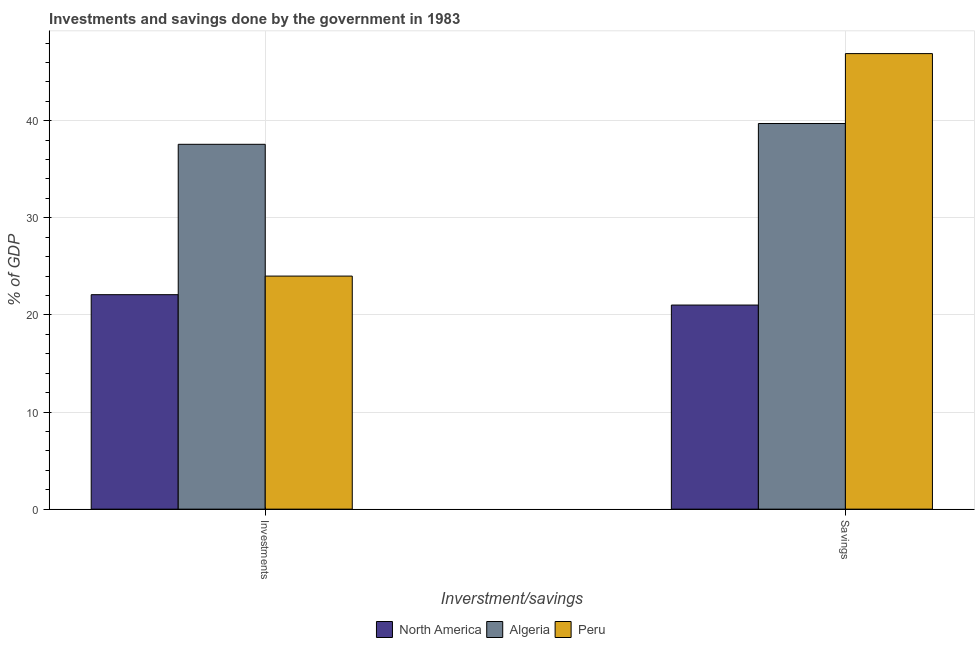How many different coloured bars are there?
Your answer should be compact. 3. How many groups of bars are there?
Ensure brevity in your answer.  2. How many bars are there on the 1st tick from the right?
Offer a very short reply. 3. What is the label of the 2nd group of bars from the left?
Give a very brief answer. Savings. What is the investments of government in North America?
Keep it short and to the point. 22.08. Across all countries, what is the maximum investments of government?
Give a very brief answer. 37.57. Across all countries, what is the minimum investments of government?
Offer a very short reply. 22.08. In which country was the savings of government maximum?
Provide a succinct answer. Peru. What is the total investments of government in the graph?
Give a very brief answer. 83.65. What is the difference between the investments of government in North America and that in Peru?
Keep it short and to the point. -1.92. What is the difference between the investments of government in North America and the savings of government in Peru?
Provide a short and direct response. -24.82. What is the average investments of government per country?
Keep it short and to the point. 27.88. What is the difference between the savings of government and investments of government in Algeria?
Give a very brief answer. 2.14. What is the ratio of the investments of government in North America to that in Peru?
Provide a succinct answer. 0.92. Is the investments of government in Algeria less than that in Peru?
Ensure brevity in your answer.  No. What does the 3rd bar from the left in Savings represents?
Provide a succinct answer. Peru. What does the 3rd bar from the right in Savings represents?
Your answer should be very brief. North America. Are all the bars in the graph horizontal?
Your answer should be very brief. No. Are the values on the major ticks of Y-axis written in scientific E-notation?
Provide a succinct answer. No. Does the graph contain any zero values?
Provide a short and direct response. No. Where does the legend appear in the graph?
Offer a terse response. Bottom center. What is the title of the graph?
Ensure brevity in your answer.  Investments and savings done by the government in 1983. Does "Kosovo" appear as one of the legend labels in the graph?
Keep it short and to the point. No. What is the label or title of the X-axis?
Provide a short and direct response. Inverstment/savings. What is the label or title of the Y-axis?
Keep it short and to the point. % of GDP. What is the % of GDP in North America in Investments?
Offer a very short reply. 22.08. What is the % of GDP in Algeria in Investments?
Provide a short and direct response. 37.57. What is the % of GDP of Peru in Investments?
Keep it short and to the point. 24. What is the % of GDP in North America in Savings?
Make the answer very short. 21.02. What is the % of GDP of Algeria in Savings?
Your answer should be very brief. 39.71. What is the % of GDP of Peru in Savings?
Your response must be concise. 46.91. Across all Inverstment/savings, what is the maximum % of GDP of North America?
Your answer should be very brief. 22.08. Across all Inverstment/savings, what is the maximum % of GDP in Algeria?
Your response must be concise. 39.71. Across all Inverstment/savings, what is the maximum % of GDP in Peru?
Give a very brief answer. 46.91. Across all Inverstment/savings, what is the minimum % of GDP in North America?
Your answer should be compact. 21.02. Across all Inverstment/savings, what is the minimum % of GDP in Algeria?
Your answer should be very brief. 37.57. Across all Inverstment/savings, what is the minimum % of GDP in Peru?
Make the answer very short. 24. What is the total % of GDP in North America in the graph?
Ensure brevity in your answer.  43.1. What is the total % of GDP in Algeria in the graph?
Offer a terse response. 77.28. What is the total % of GDP in Peru in the graph?
Give a very brief answer. 70.91. What is the difference between the % of GDP in North America in Investments and that in Savings?
Make the answer very short. 1.07. What is the difference between the % of GDP in Algeria in Investments and that in Savings?
Give a very brief answer. -2.14. What is the difference between the % of GDP in Peru in Investments and that in Savings?
Your answer should be compact. -22.91. What is the difference between the % of GDP of North America in Investments and the % of GDP of Algeria in Savings?
Your answer should be compact. -17.62. What is the difference between the % of GDP in North America in Investments and the % of GDP in Peru in Savings?
Keep it short and to the point. -24.82. What is the difference between the % of GDP of Algeria in Investments and the % of GDP of Peru in Savings?
Your answer should be very brief. -9.34. What is the average % of GDP of North America per Inverstment/savings?
Your answer should be compact. 21.55. What is the average % of GDP of Algeria per Inverstment/savings?
Your answer should be compact. 38.64. What is the average % of GDP of Peru per Inverstment/savings?
Keep it short and to the point. 35.45. What is the difference between the % of GDP in North America and % of GDP in Algeria in Investments?
Give a very brief answer. -15.49. What is the difference between the % of GDP in North America and % of GDP in Peru in Investments?
Offer a terse response. -1.92. What is the difference between the % of GDP of Algeria and % of GDP of Peru in Investments?
Your response must be concise. 13.57. What is the difference between the % of GDP in North America and % of GDP in Algeria in Savings?
Provide a short and direct response. -18.69. What is the difference between the % of GDP in North America and % of GDP in Peru in Savings?
Offer a terse response. -25.89. What is the difference between the % of GDP of Algeria and % of GDP of Peru in Savings?
Keep it short and to the point. -7.2. What is the ratio of the % of GDP of North America in Investments to that in Savings?
Give a very brief answer. 1.05. What is the ratio of the % of GDP of Algeria in Investments to that in Savings?
Make the answer very short. 0.95. What is the ratio of the % of GDP of Peru in Investments to that in Savings?
Keep it short and to the point. 0.51. What is the difference between the highest and the second highest % of GDP of North America?
Offer a terse response. 1.07. What is the difference between the highest and the second highest % of GDP in Algeria?
Make the answer very short. 2.14. What is the difference between the highest and the second highest % of GDP of Peru?
Offer a terse response. 22.91. What is the difference between the highest and the lowest % of GDP of North America?
Provide a short and direct response. 1.07. What is the difference between the highest and the lowest % of GDP of Algeria?
Provide a succinct answer. 2.14. What is the difference between the highest and the lowest % of GDP in Peru?
Make the answer very short. 22.91. 